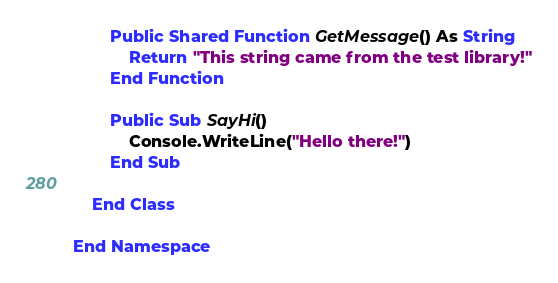<code> <loc_0><loc_0><loc_500><loc_500><_VisualBasic_>        Public Shared Function GetMessage() As String
            Return "This string came from the test library!"
        End Function

        Public Sub SayHi()
            Console.WriteLine("Hello there!")
        End Sub

    End Class

End Namespace
</code> 